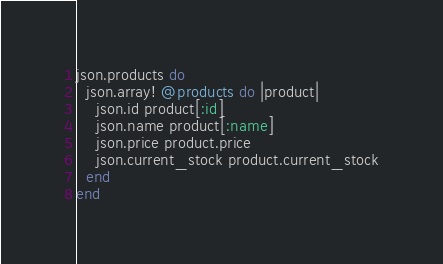<code> <loc_0><loc_0><loc_500><loc_500><_Ruby_>json.products do
  json.array! @products do |product|
    json.id product[:id]
    json.name product[:name]
    json.price product.price
    json.current_stock product.current_stock
  end
end
</code> 